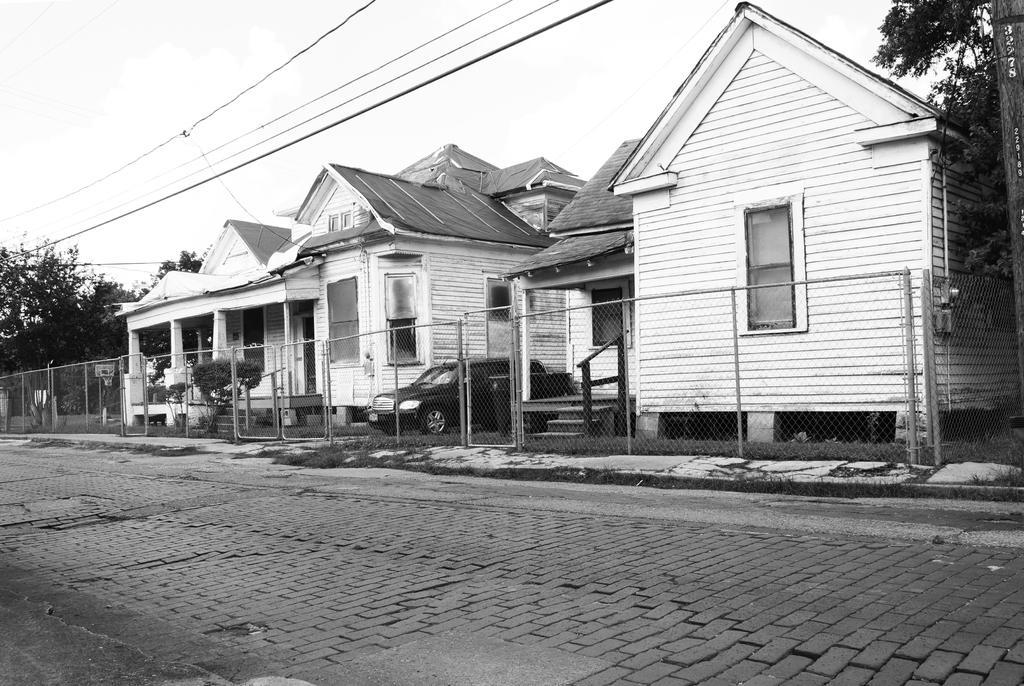In one or two sentences, can you explain what this image depicts? This is a black and white image. These are the houses with windows. This looks like a fence. I can see a car, which is parked. These are the small bushes. This looks like a pole. These are the trees. I think these are the current wires hanging. 